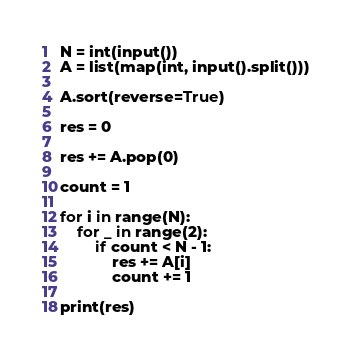Convert code to text. <code><loc_0><loc_0><loc_500><loc_500><_Python_>N = int(input())
A = list(map(int, input().split()))

A.sort(reverse=True)

res = 0

res += A.pop(0)

count = 1

for i in range(N):
    for _ in range(2):
        if count < N - 1:
            res += A[i]
            count += 1

print(res)</code> 